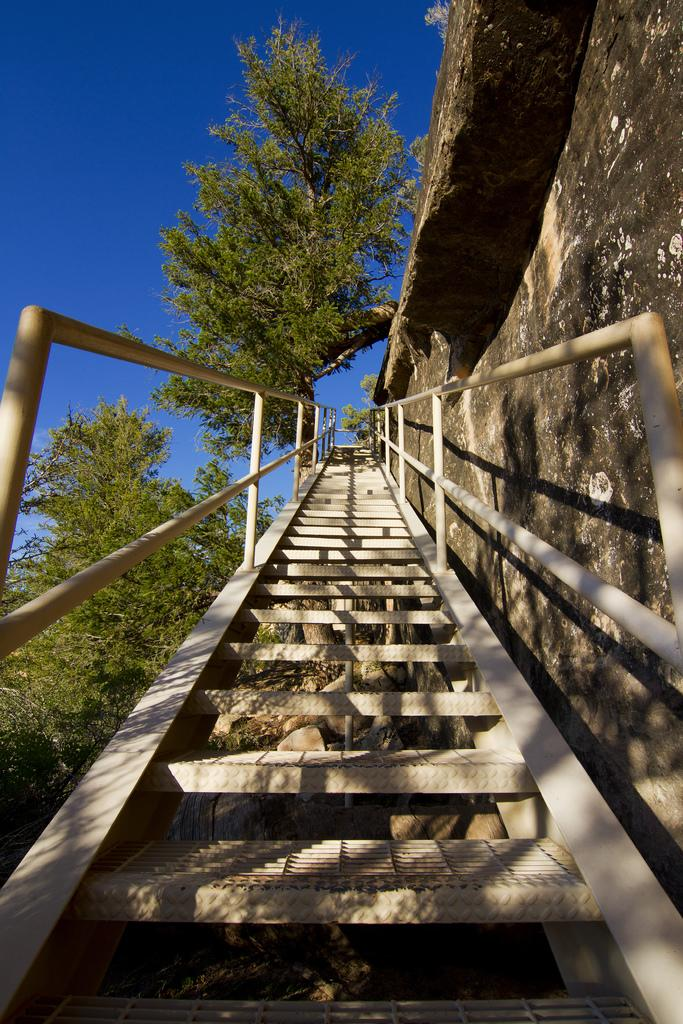What type of structure is present in the image? There are stairs with staircase holders in the image. What else can be seen in the image besides the stairs? There is a wall in the image. What type of vegetation is visible in the image? There are trees with branches and leaves in the image. What is visible in the background of the image? The sky is visible in the image. Can you see a tiger walking on the branches of the trees in the image? No, there is no tiger present in the image. 